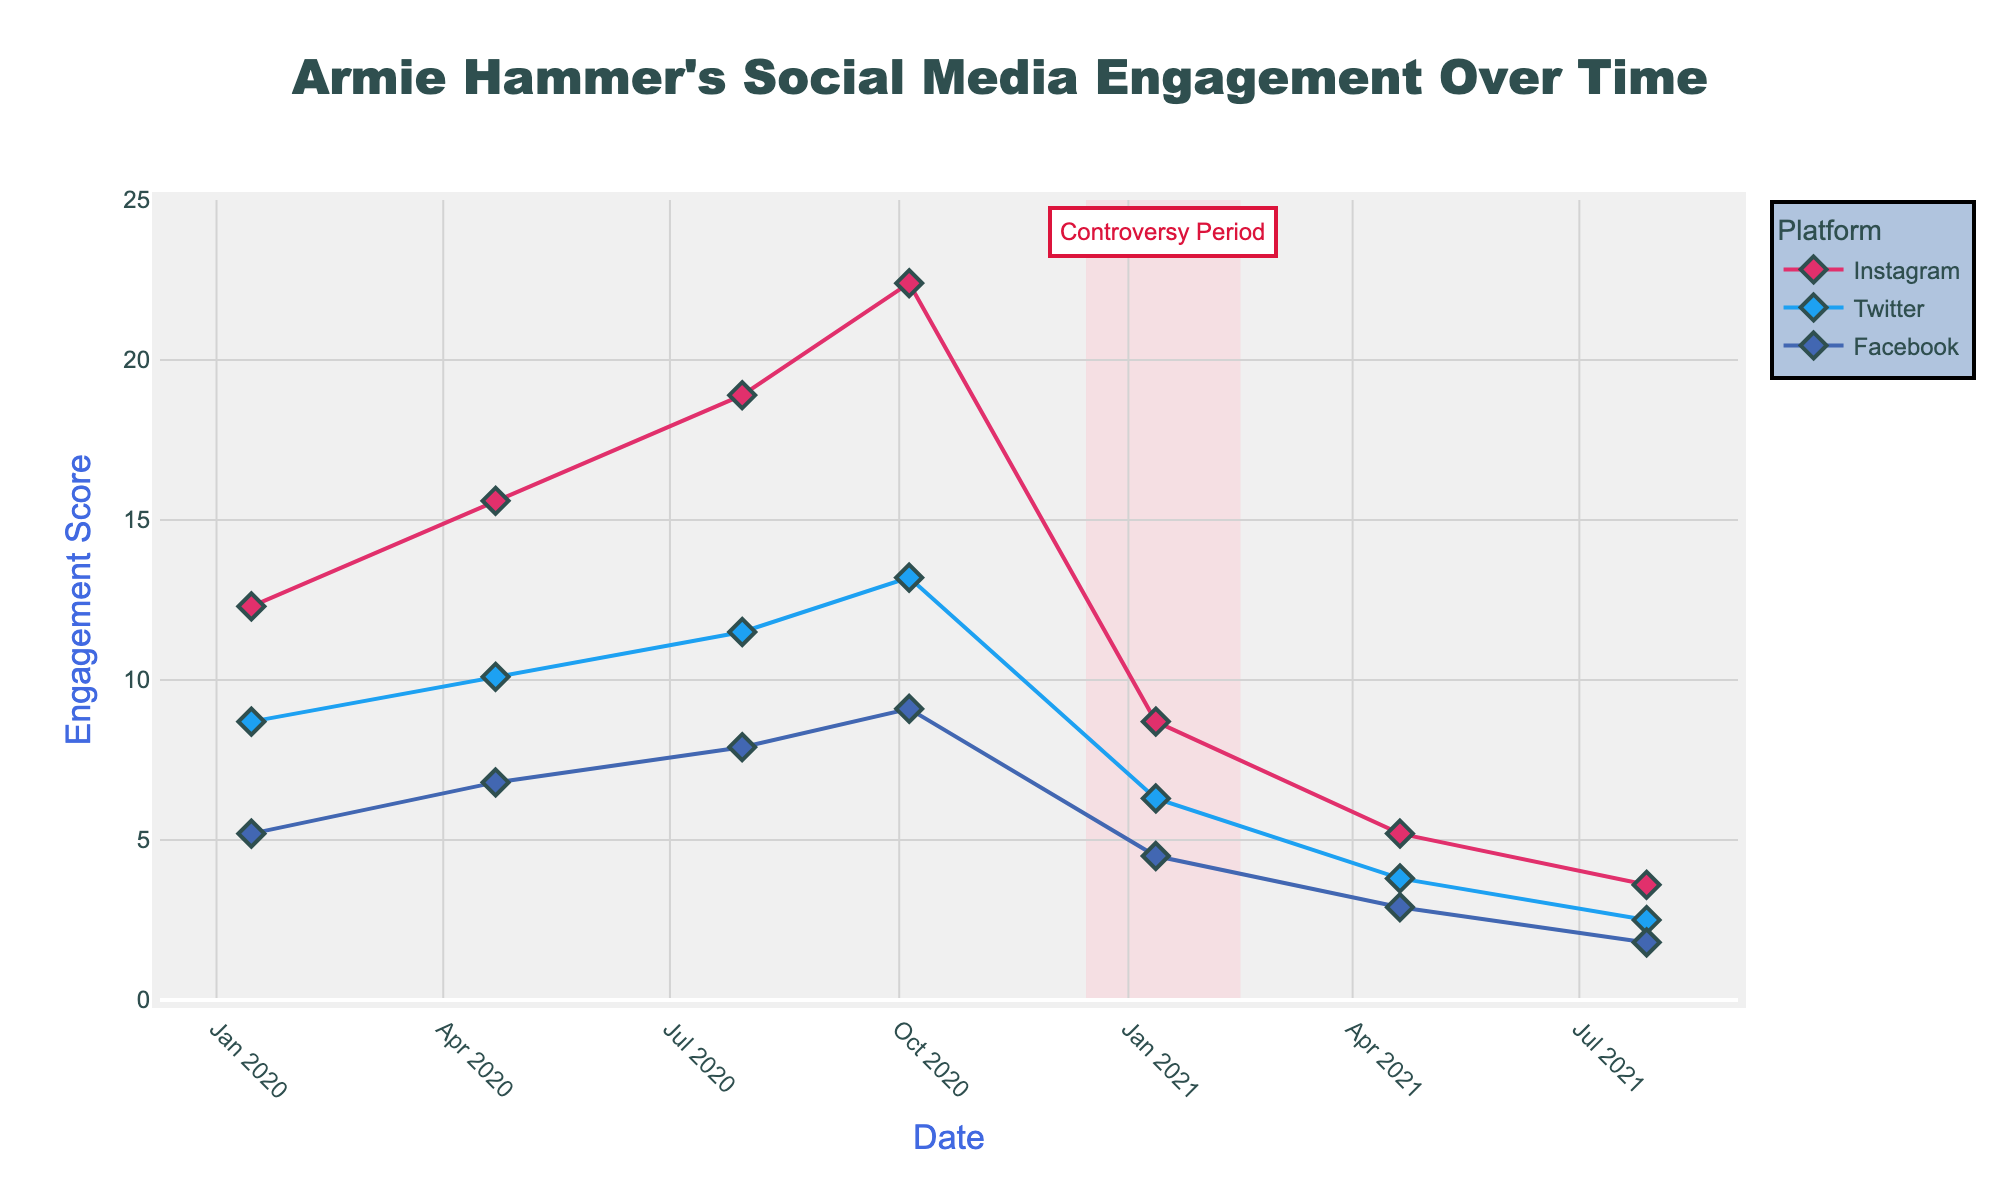What is the title of the plot? The title is typically displayed at the top of the figure. In this case, it reads: "Armie Hammer's Social Media Engagement Over Time".
Answer: Armie Hammer's Social Media Engagement Over Time Which platform has the highest engagement score on the 5th of October, 2020? Check the marks for each platform on October 5, 2020, and compare the scores. Instagram has the highest engagement score at 22.4 on this date.
Answer: Instagram How did the engagement scores change for Instagram from January 15, 2020, to July 28, 2021? Clicking on each mark for Instagram on the respective dates reveals that the scores started at 12.3, increased to a peak of 22.4, and then decreased to 3.6 over the given period.
Answer: Increased, then decreased What is the average engagement score for Facebook across all the displayed dates? Locate all the Facebook engagement scores in the plot and calculate their average: (5.2 + 6.8 + 7.9 + 9.1 + 4.5 + 2.9 + 1.8) / 7 = 5.46.
Answer: 5.46 Compare the engagement scores for Twitter and Facebook on April 22, 2020. Which is higher? Find the marks for both Twitter and Facebook on April 22, 2020. Twitter's score is 10.1, whereas Facebook's score is 6.8. Hence, Twitter's score is higher.
Answer: Twitter Was there any significant period highlighted in the plot, and what is it labeled as? The highlighted period is marked with a light yellow background between December 15, 2020, and February 15, 2021. It is labeled as "Controversy Period".
Answer: Controversy Period Which date showed the lowest engagement score for Instagram? By observing the lowest point on the Instagram line, we notice it is on July 28, 2021, with a score of 3.6.
Answer: July 28, 2021 What trend can be observed for Twitter's engagement scores over time? The engagement scores for Twitter generally follow a decreasing trend after peaking on October 5, 2020, indicating a drop in engagement over time.
Answer: Decreasing trend 